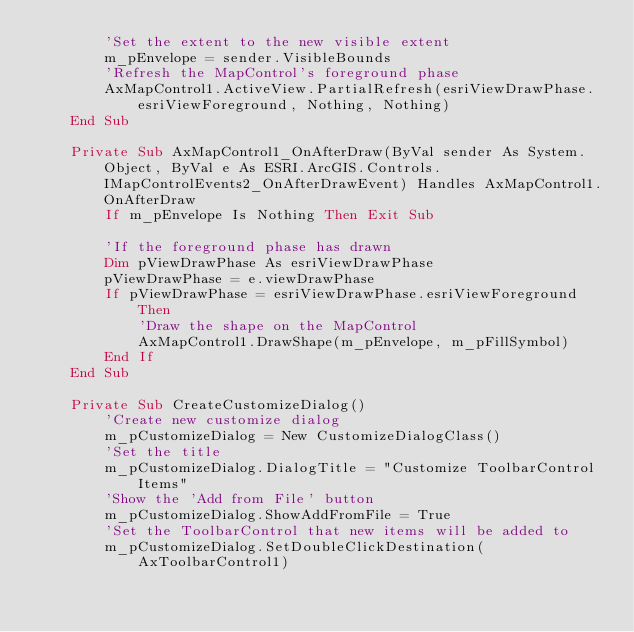<code> <loc_0><loc_0><loc_500><loc_500><_VisualBasic_>        'Set the extent to the new visible extent
        m_pEnvelope = sender.VisibleBounds
        'Refresh the MapControl's foreground phase
        AxMapControl1.ActiveView.PartialRefresh(esriViewDrawPhase.esriViewForeground, Nothing, Nothing)
    End Sub

    Private Sub AxMapControl1_OnAfterDraw(ByVal sender As System.Object, ByVal e As ESRI.ArcGIS.Controls.IMapControlEvents2_OnAfterDrawEvent) Handles AxMapControl1.OnAfterDraw
        If m_pEnvelope Is Nothing Then Exit Sub

        'If the foreground phase has drawn
        Dim pViewDrawPhase As esriViewDrawPhase
        pViewDrawPhase = e.viewDrawPhase
        If pViewDrawPhase = esriViewDrawPhase.esriViewForeground Then
            'Draw the shape on the MapControl
            AxMapControl1.DrawShape(m_pEnvelope, m_pFillSymbol)
        End If
    End Sub

    Private Sub CreateCustomizeDialog()
        'Create new customize dialog 
        m_pCustomizeDialog = New CustomizeDialogClass()
        'Set the title
        m_pCustomizeDialog.DialogTitle = "Customize ToolbarControl Items"
        'Show the 'Add from File' button
        m_pCustomizeDialog.ShowAddFromFile = True
        'Set the ToolbarControl that new items will be added to
        m_pCustomizeDialog.SetDoubleClickDestination(AxToolbarControl1)
</code> 